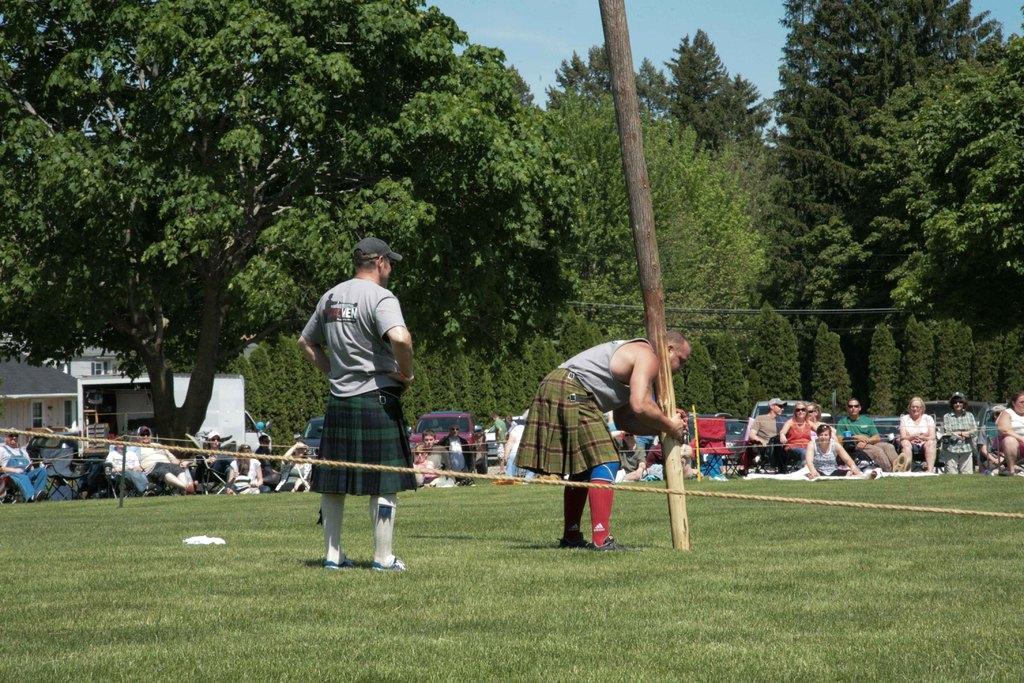Please provide a concise description of this image. There is a person standing and wore cap and this person holding a wooden pole and we can see grass and rope. Background we can see trees,houses,people and sky. 